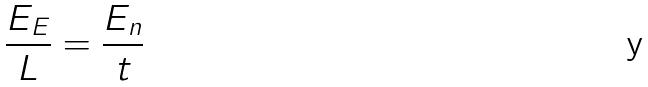Convert formula to latex. <formula><loc_0><loc_0><loc_500><loc_500>\frac { E _ { E } } { L } = \frac { E _ { n } } { t }</formula> 